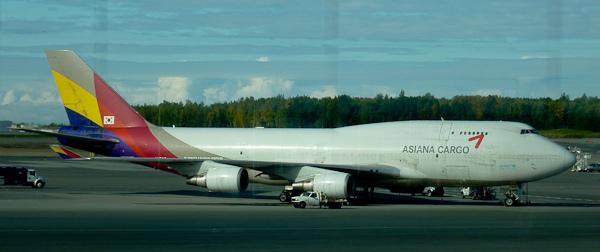How many people fit in this plane?
Keep it brief. 200. Are there service vehicles?
Keep it brief. Yes. Where is the plane?
Give a very brief answer. Airport. What symbol is on the plane's tail?
Give a very brief answer. Circle. What number so you see?
Be succinct. 0. What colors are on the plain's trail?
Quick response, please. Red blue and yellow. What is surrounding the field?
Give a very brief answer. Trees. Is the front of plane pointy or flat?
Quick response, please. Pointy. What is the name of this plane?
Answer briefly. Asiana cargo. What type of leaf is on the tail of the planes?
Write a very short answer. Maple. 